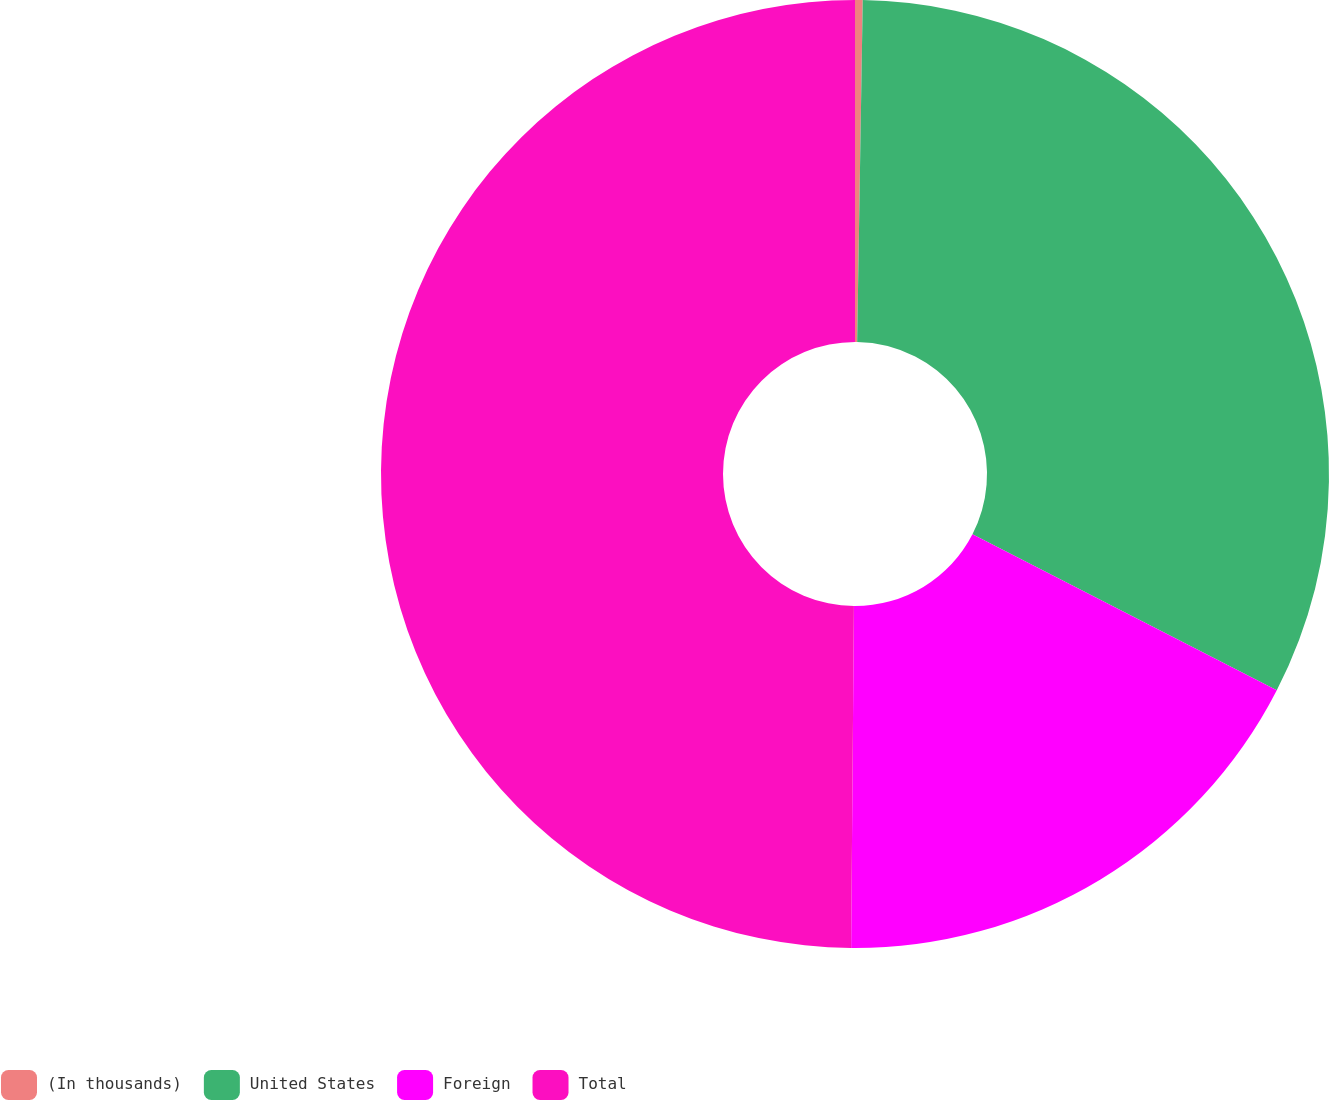<chart> <loc_0><loc_0><loc_500><loc_500><pie_chart><fcel>(In thousands)<fcel>United States<fcel>Foreign<fcel>Total<nl><fcel>0.26%<fcel>32.28%<fcel>17.59%<fcel>49.87%<nl></chart> 